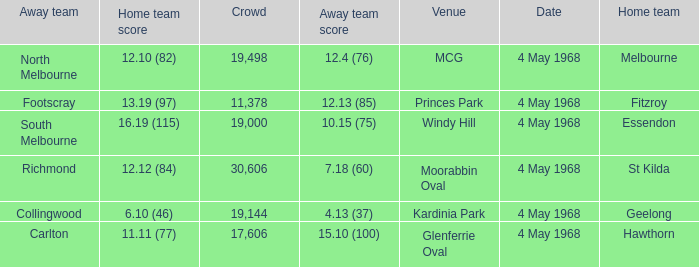What team played at Moorabbin Oval to a crowd of 19,144? St Kilda. 